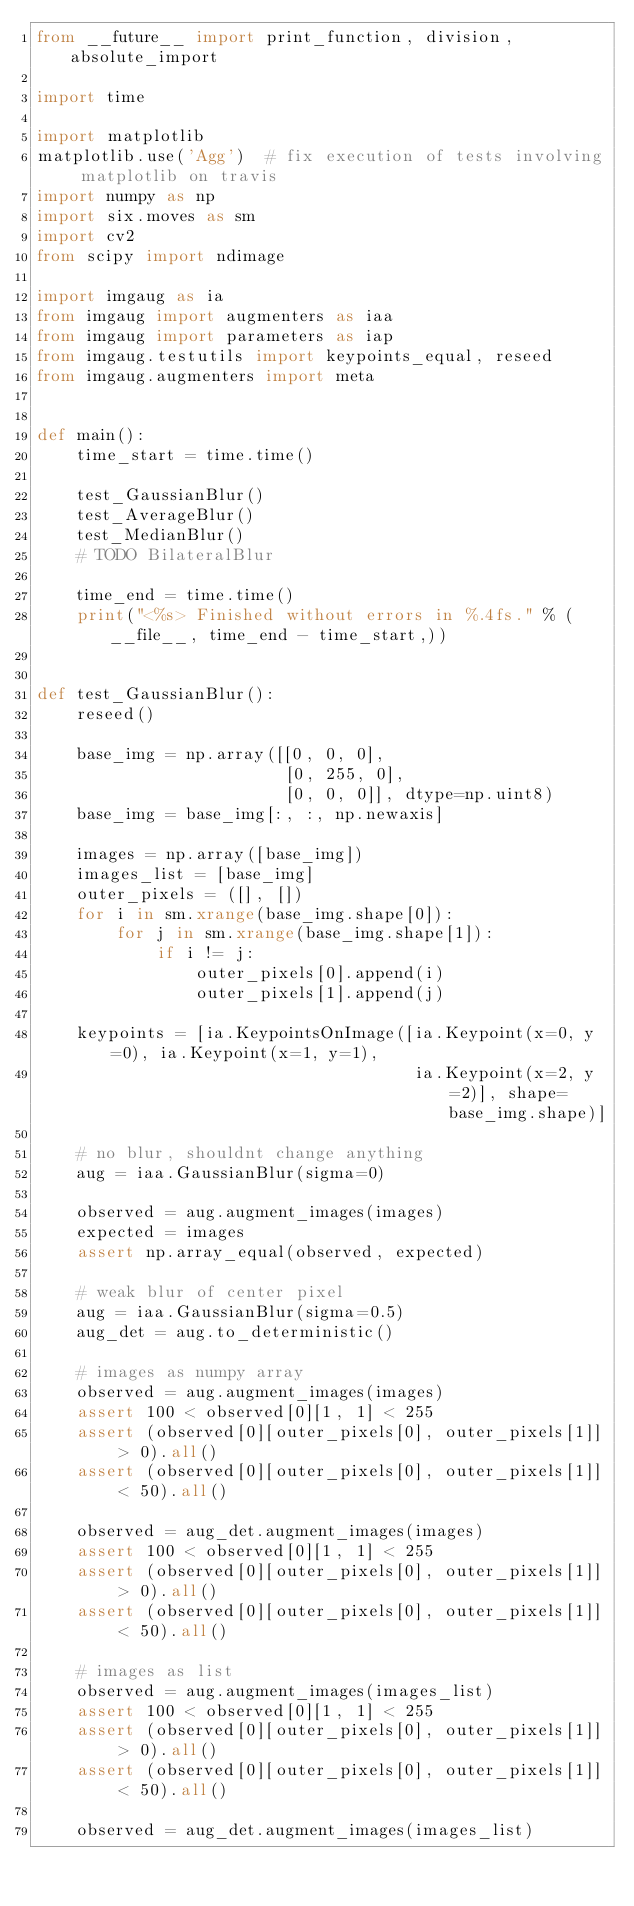<code> <loc_0><loc_0><loc_500><loc_500><_Python_>from __future__ import print_function, division, absolute_import

import time

import matplotlib
matplotlib.use('Agg')  # fix execution of tests involving matplotlib on travis
import numpy as np
import six.moves as sm
import cv2
from scipy import ndimage

import imgaug as ia
from imgaug import augmenters as iaa
from imgaug import parameters as iap
from imgaug.testutils import keypoints_equal, reseed
from imgaug.augmenters import meta


def main():
    time_start = time.time()

    test_GaussianBlur()
    test_AverageBlur()
    test_MedianBlur()
    # TODO BilateralBlur

    time_end = time.time()
    print("<%s> Finished without errors in %.4fs." % (__file__, time_end - time_start,))


def test_GaussianBlur():
    reseed()

    base_img = np.array([[0, 0, 0],
                         [0, 255, 0],
                         [0, 0, 0]], dtype=np.uint8)
    base_img = base_img[:, :, np.newaxis]

    images = np.array([base_img])
    images_list = [base_img]
    outer_pixels = ([], [])
    for i in sm.xrange(base_img.shape[0]):
        for j in sm.xrange(base_img.shape[1]):
            if i != j:
                outer_pixels[0].append(i)
                outer_pixels[1].append(j)

    keypoints = [ia.KeypointsOnImage([ia.Keypoint(x=0, y=0), ia.Keypoint(x=1, y=1),
                                      ia.Keypoint(x=2, y=2)], shape=base_img.shape)]

    # no blur, shouldnt change anything
    aug = iaa.GaussianBlur(sigma=0)

    observed = aug.augment_images(images)
    expected = images
    assert np.array_equal(observed, expected)

    # weak blur of center pixel
    aug = iaa.GaussianBlur(sigma=0.5)
    aug_det = aug.to_deterministic()

    # images as numpy array
    observed = aug.augment_images(images)
    assert 100 < observed[0][1, 1] < 255
    assert (observed[0][outer_pixels[0], outer_pixels[1]] > 0).all()
    assert (observed[0][outer_pixels[0], outer_pixels[1]] < 50).all()

    observed = aug_det.augment_images(images)
    assert 100 < observed[0][1, 1] < 255
    assert (observed[0][outer_pixels[0], outer_pixels[1]] > 0).all()
    assert (observed[0][outer_pixels[0], outer_pixels[1]] < 50).all()

    # images as list
    observed = aug.augment_images(images_list)
    assert 100 < observed[0][1, 1] < 255
    assert (observed[0][outer_pixels[0], outer_pixels[1]] > 0).all()
    assert (observed[0][outer_pixels[0], outer_pixels[1]] < 50).all()

    observed = aug_det.augment_images(images_list)</code> 